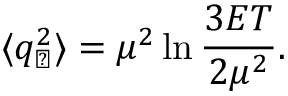<formula> <loc_0><loc_0><loc_500><loc_500>\langle q _ { \perp } ^ { 2 } \rangle = \mu ^ { 2 } \ln \frac { 3 E T } { 2 \mu ^ { 2 } } .</formula> 